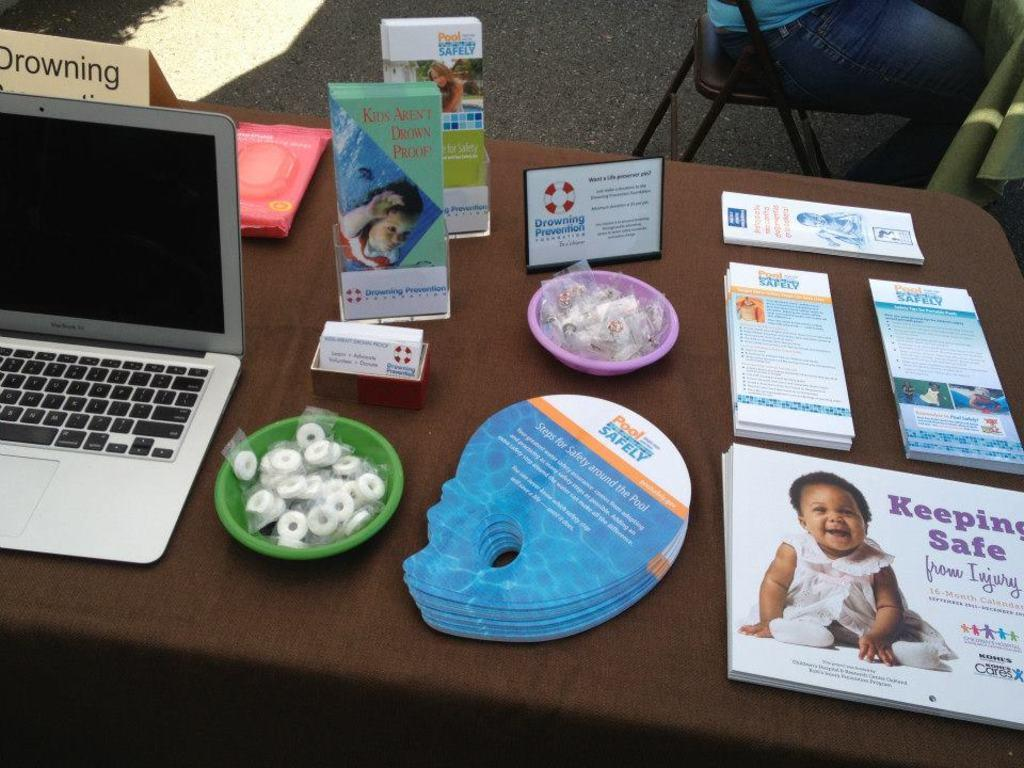Provide a one-sentence caption for the provided image. The table has a laptop on it next to brochures for keeping safe and pool safety. 